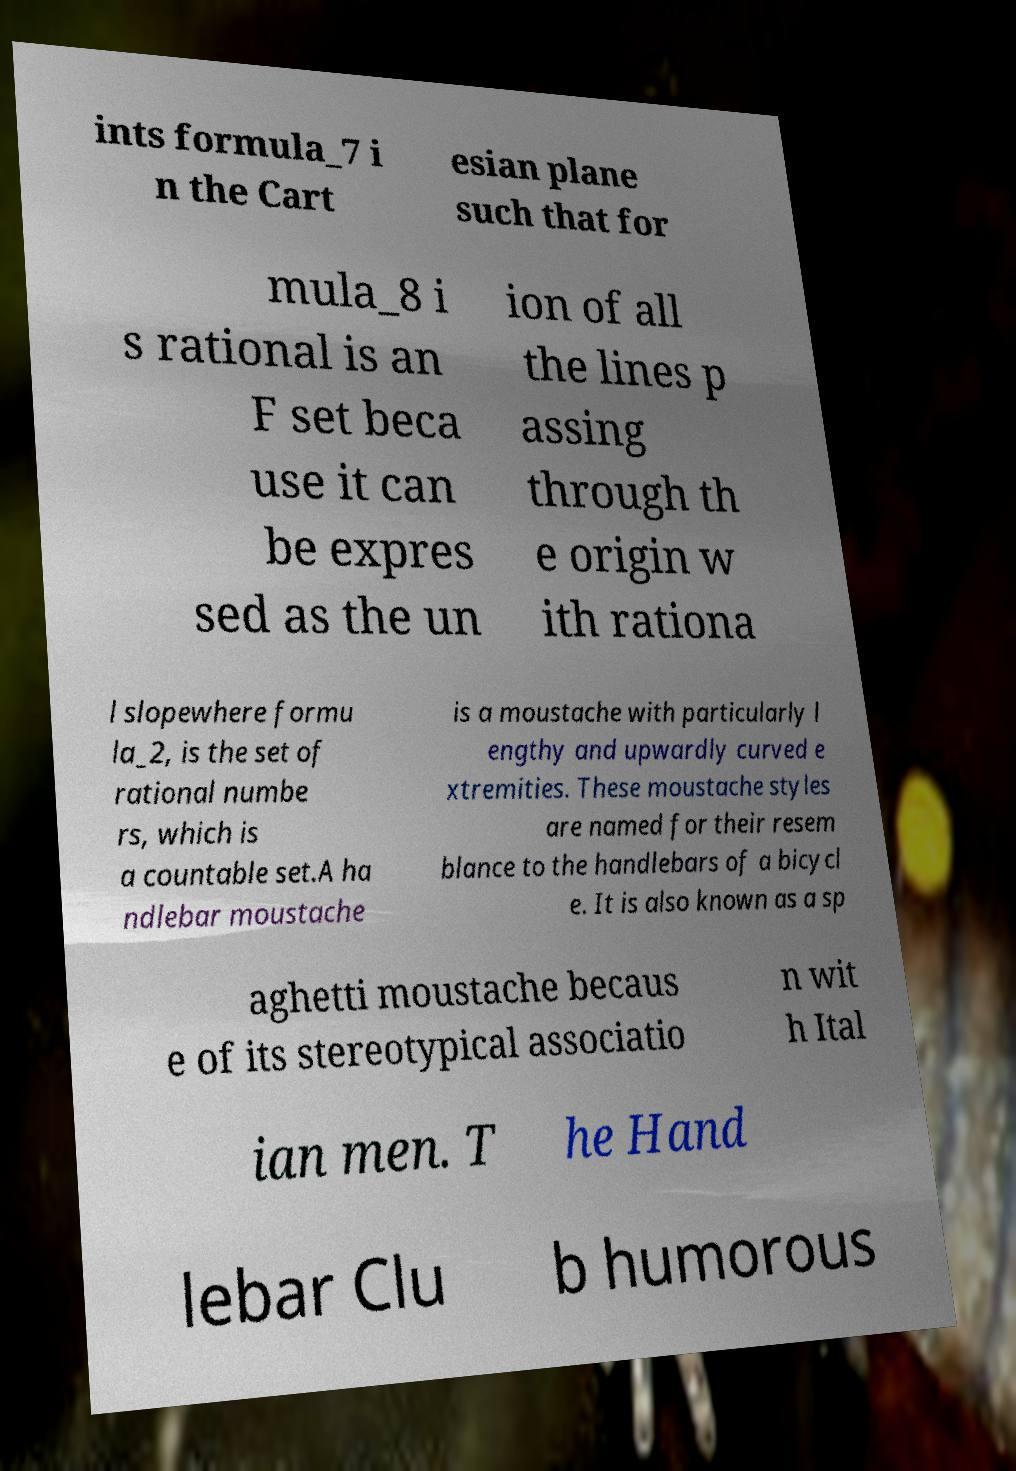What messages or text are displayed in this image? I need them in a readable, typed format. ints formula_7 i n the Cart esian plane such that for mula_8 i s rational is an F set beca use it can be expres sed as the un ion of all the lines p assing through th e origin w ith rationa l slopewhere formu la_2, is the set of rational numbe rs, which is a countable set.A ha ndlebar moustache is a moustache with particularly l engthy and upwardly curved e xtremities. These moustache styles are named for their resem blance to the handlebars of a bicycl e. It is also known as a sp aghetti moustache becaus e of its stereotypical associatio n wit h Ital ian men. T he Hand lebar Clu b humorous 